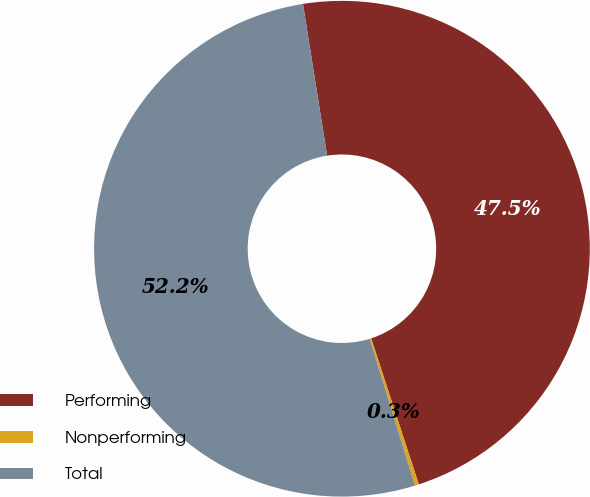<chart> <loc_0><loc_0><loc_500><loc_500><pie_chart><fcel>Performing<fcel>Nonperforming<fcel>Total<nl><fcel>47.5%<fcel>0.26%<fcel>52.25%<nl></chart> 